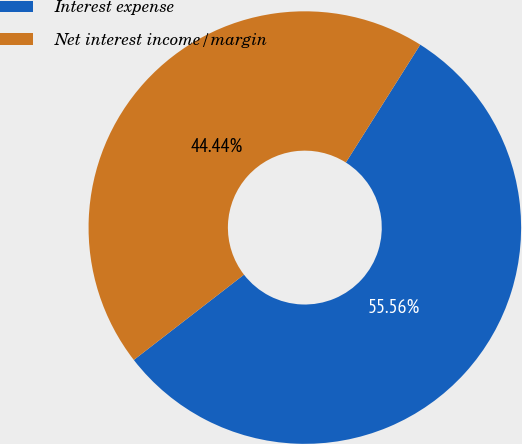<chart> <loc_0><loc_0><loc_500><loc_500><pie_chart><fcel>Interest expense<fcel>Net interest income/margin<nl><fcel>55.56%<fcel>44.44%<nl></chart> 